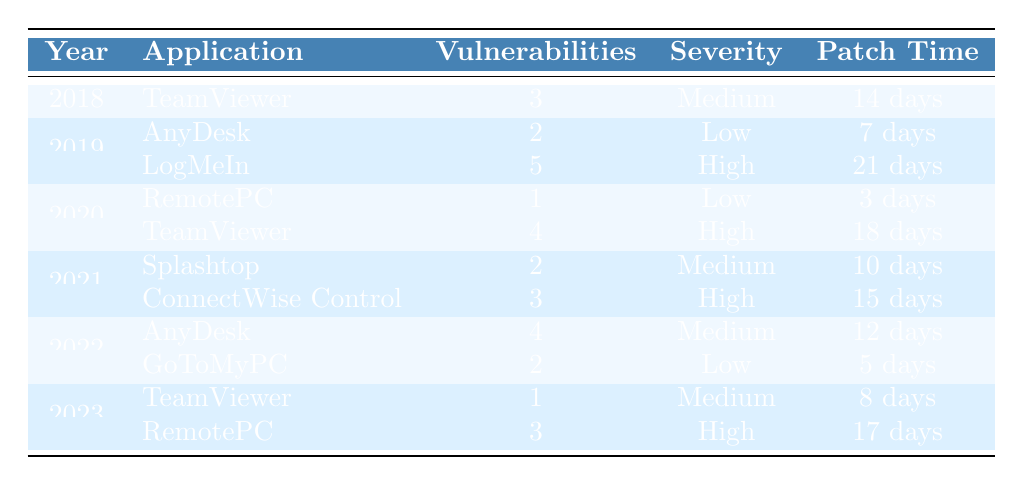What application had the highest number of vulnerabilities detected in 2019? According to the table, LogMeIn had 5 vulnerabilities detected in 2019, which is the highest for that year. AnyDesk had 2 vulnerabilities.
Answer: LogMeIn What was the severity level of the vulnerabilities detected in RemotePC in 2020? The table indicates that RemotePC had 1 vulnerability detected in 2020, which was classified as Low severity.
Answer: Low How many total vulnerabilities were detected across all applications in 2022? In 2022, AnyDesk had 4 vulnerabilities and GoToMyPC had 2. Summing these gives us 4 + 2 = 6.
Answer: 6 What is the patch time for ConnectWise Control? The table shows that ConnectWise Control had a patch time of 15 days for its vulnerabilities detected in 2021.
Answer: 15 days Which application experienced the least number of vulnerabilities detected in 2020? RemotePC had only 1 vulnerability detected in 2020, which is the least among all applications that year. TeamViewer had 4 vulnerabilities.
Answer: RemotePC Was there a year when TeamViewer had a high severity level for its vulnerabilities? Yes, in 2020, TeamViewer had 4 vulnerabilities detected, which were categorized as High severity.
Answer: Yes What was the average number of vulnerabilities detected per year for LogMeIn from 2019 to 2021? LogMeIn had 5 vulnerabilities in 2019 and none listed for 2020 or 2021, so the average would be (5 + 0 + 0) / 3 = 1.67.
Answer: 1.67 Is there any year where the patch time was longer than 20 days? Yes, in 2019, LogMeIn had a patch time of 21 days, which is longer than 20 days.
Answer: Yes How many applications had a severity level of High in 2023? In 2023, only RemotePC had a severity level of High for its detected vulnerabilities; TeamViewer had a Medium severity.
Answer: 1 Which application consistently had vulnerabilities detected across the years 2018 to 2023? TeamViewer was the only application that had detected vulnerabilities in 2018, 2020, 2022, and 2023. AnyDesk and LogMeIn were only present in specific years.
Answer: TeamViewer 